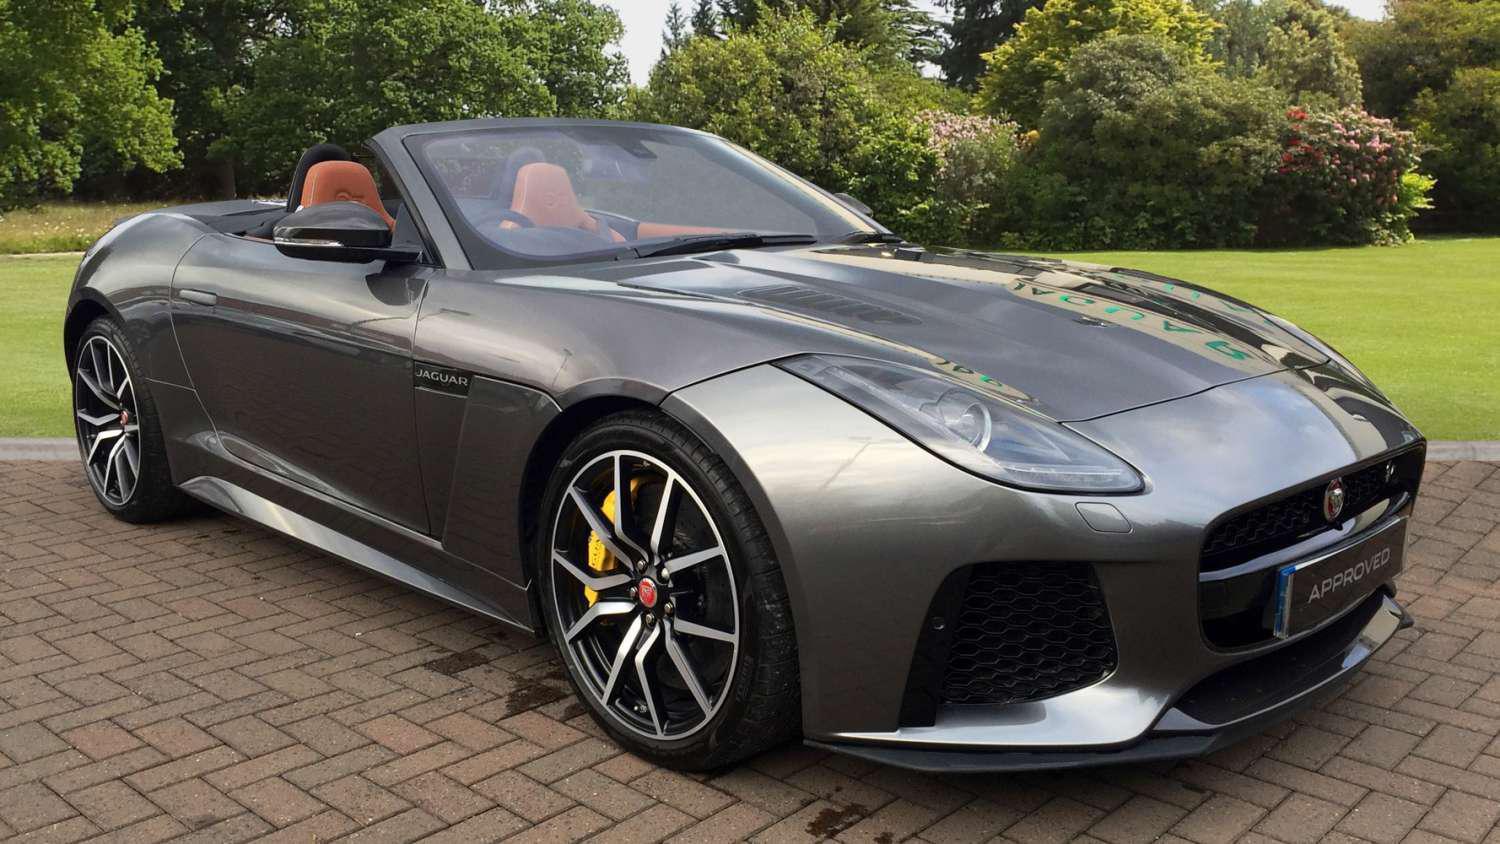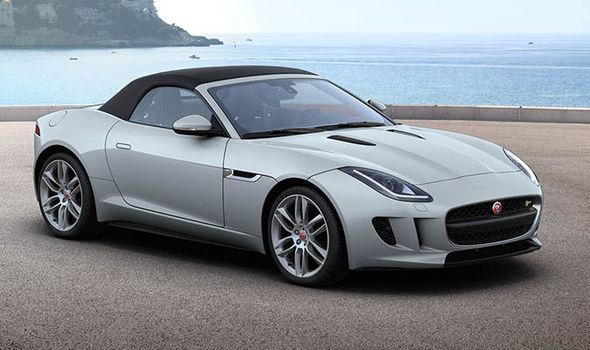The first image is the image on the left, the second image is the image on the right. Assess this claim about the two images: "The cars in the left and right images face the same direction, but one has its top up and one has its top down.". Correct or not? Answer yes or no. Yes. The first image is the image on the left, the second image is the image on the right. Assess this claim about the two images: "There is one car with its top down and one car with the top up". Correct or not? Answer yes or no. Yes. 